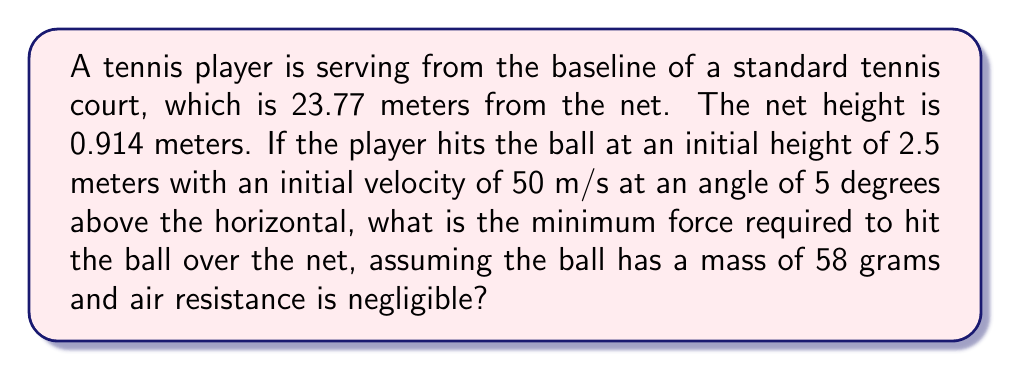Show me your answer to this math problem. Let's approach this step-by-step:

1) First, we need to determine if the ball will clear the net. We can use the projectile motion equations for this.

2) The time it takes for the ball to reach the net:
   $$t = \frac{23.77}{50 \cos(5°)} \approx 0.477 \text{ s}$$

3) The height of the ball when it reaches the net:
   $$y = 2.5 + (50 \sin(5°))t - \frac{1}{2}gt^2$$
   $$y = 2.5 + (50 \sin(5°))(0.477) - \frac{1}{2}(9.8)(0.477)^2 \approx 3.95 \text{ m}$$

4) The ball clears the net as 3.95 m > 0.914 m.

5) To find the force, we use Newton's Second Law: $F = ma$

6) The acceleration is the change in velocity over time. The initial velocity components are:
   $$v_x = 50 \cos(5°) \approx 49.81 \text{ m/s}$$
   $$v_y = 50 \sin(5°) \approx 4.36 \text{ m/s}$$

7) The final velocity at impact is the same as the initial velocity (neglecting air resistance).

8) The time of impact is very short, let's assume 0.005 seconds.

9) The acceleration during impact:
   $$a = \frac{\sqrt{49.81^2 + 4.36^2}}{0.005} = 10000 \text{ m/s}^2$$

10) Now we can calculate the force:
    $$F = (0.058 \text{ kg})(10000 \text{ m/s}^2) = 580 \text{ N}$$
Answer: 580 N 